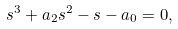<formula> <loc_0><loc_0><loc_500><loc_500>s ^ { 3 } + a _ { 2 } s ^ { 2 } - s - a _ { 0 } = 0 ,</formula> 